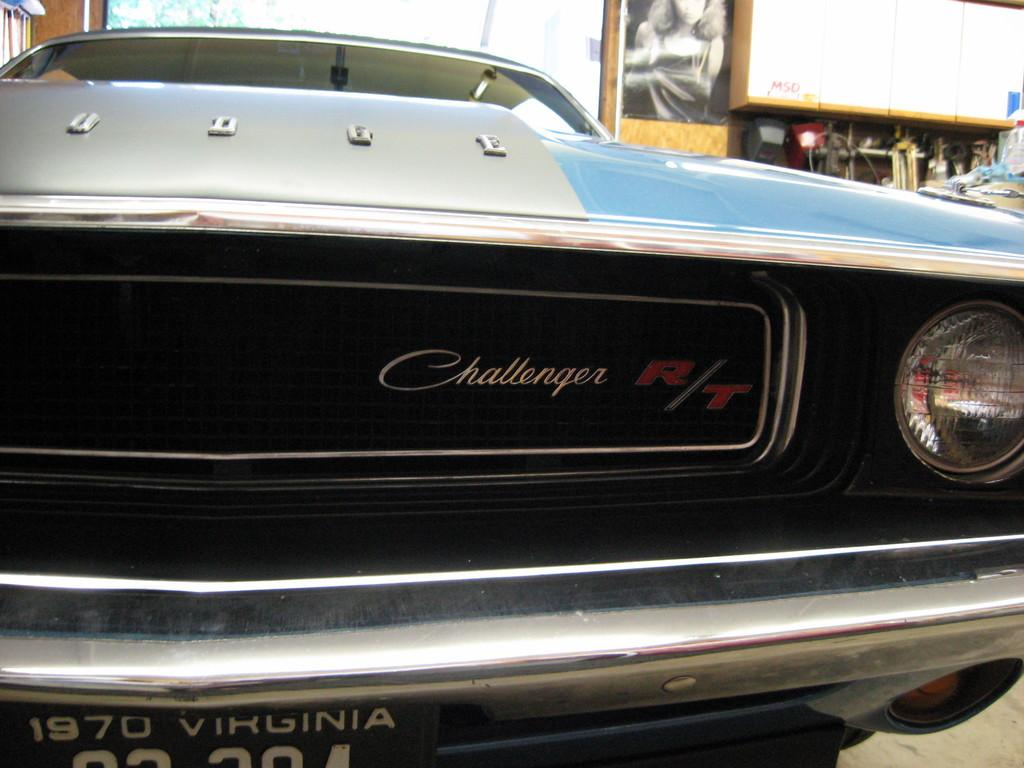What is the main subject of the image? There is a car in the image. What can be seen in the background of the image? There is a shed and a board in the background of the image. What is attached to the board? A poster is attached to the board. Can you tell me how many guitars are leaning against the car in the image? There are no guitars present in the image; it only features a car, a shed, a board, and a poster. Is there a bottle of water visible on the board in the image? There is no bottle of water present on the board or anywhere else in the image. 